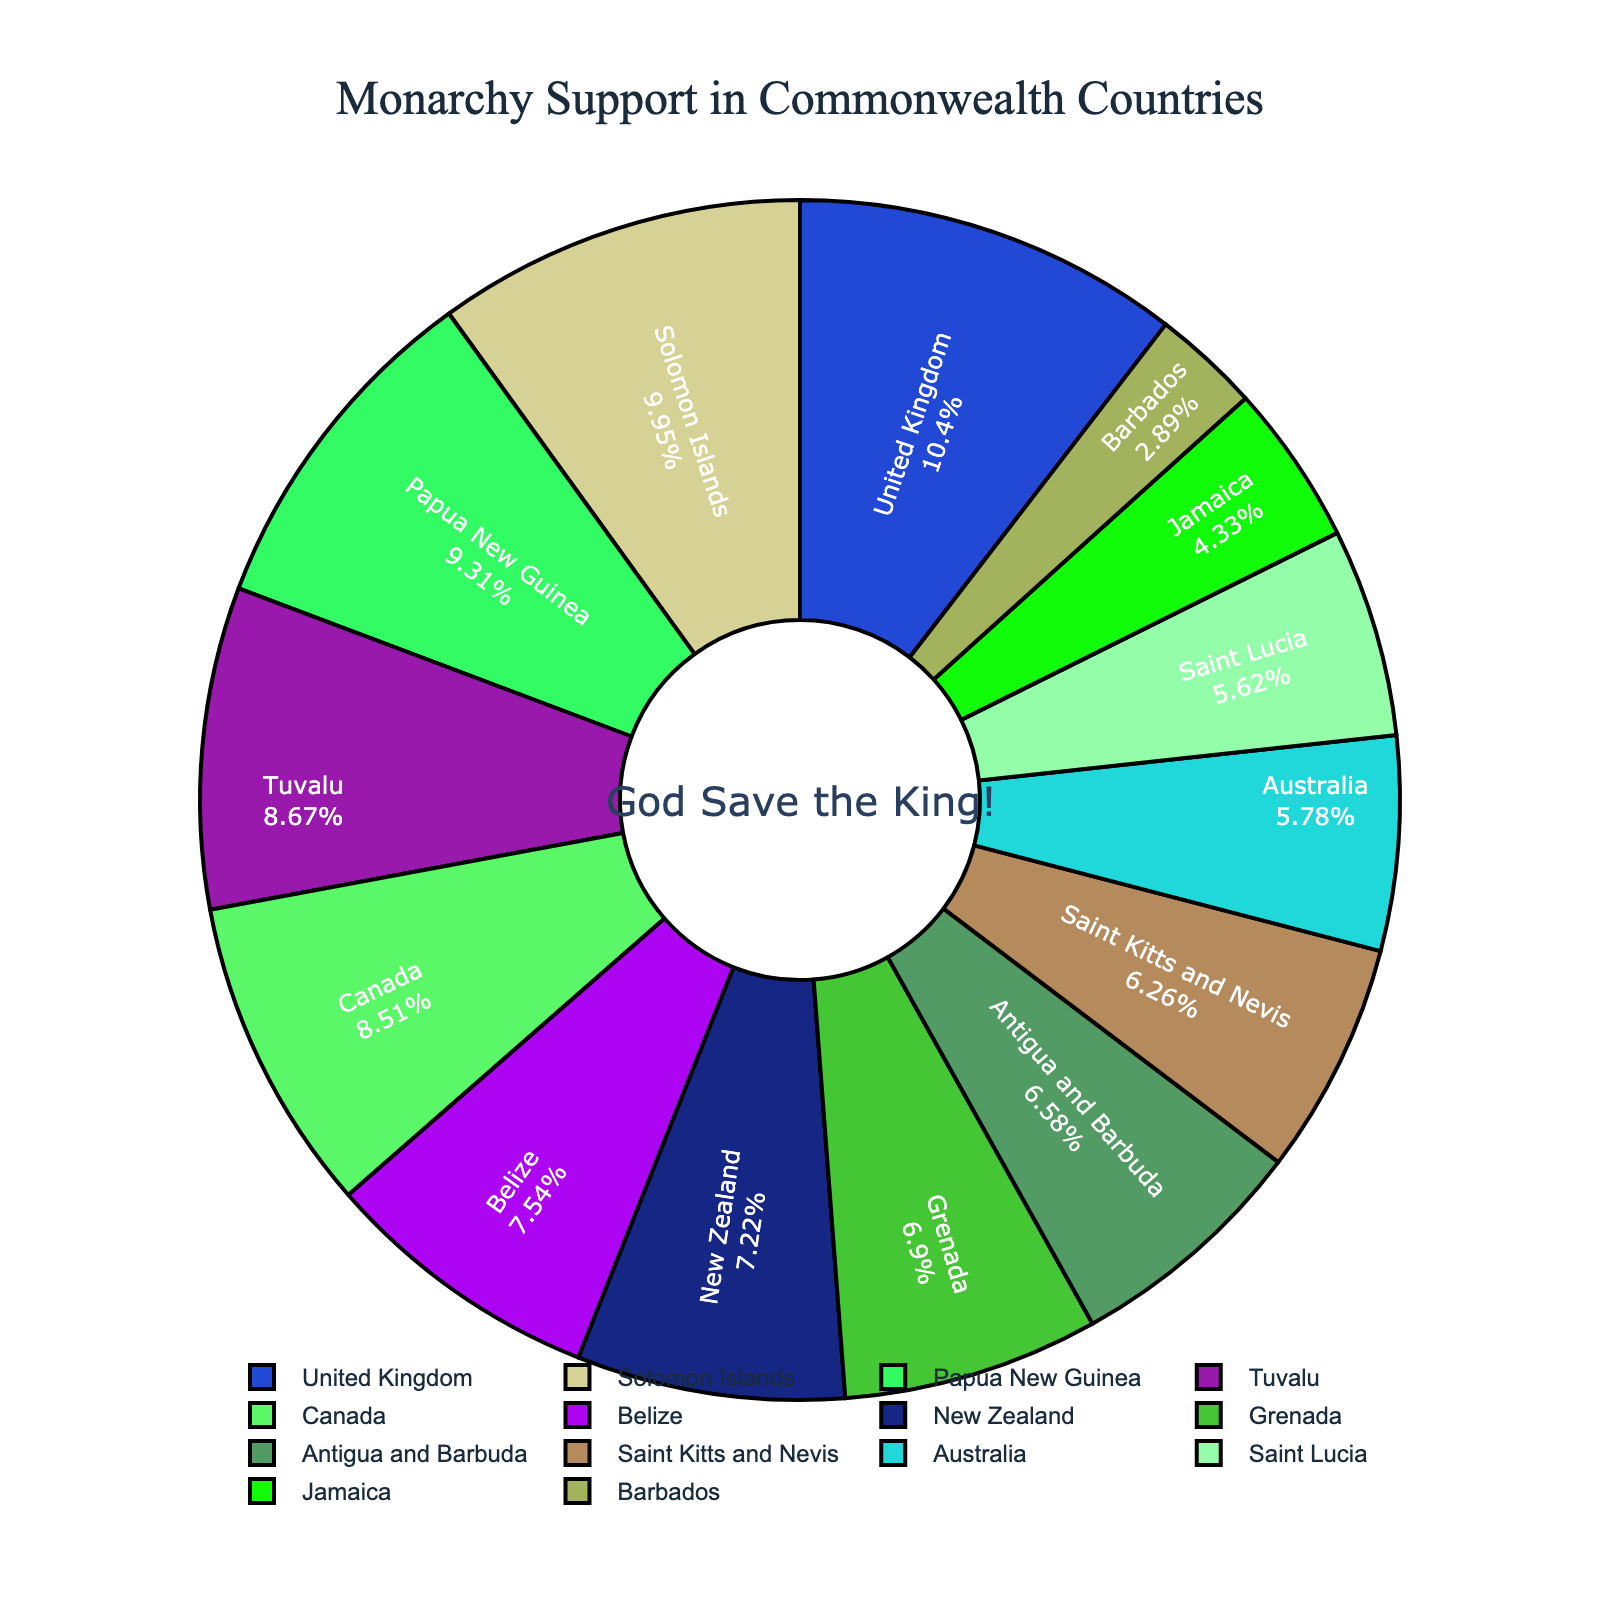What percentage of support does the United Kingdom have and how does it compare to Canada? The United Kingdom has 65% support, and Canada has 53%. To compare, subtract Canada's support from the United Kingdom's support: 65% - 53% = 12%.
Answer: 12% Which country shows the highest support for the British monarchy, and which shows the lowest? By examining the pie chart, we see that the Solomon Islands have the highest support at 62%, and Barbados has the lowest support at 18%.
Answer: Solomon Islands, Barbados If you combine the support percentages of New Zealand, Australia, and Jamaica, what total do you get? Add the support percentages of New Zealand (45%), Australia (36%), and Jamaica (27%): 45% + 36% + 27% = 108%.
Answer: 108% What is the average support percentage for the countries listed in the chart? To find the average, sum all support percentages and divide by the number of countries. The total sum is 65+53+36+45+27+18+58+62+41+39+47+43+35+54 = 623. There are 14 countries, so the average is 623/14 ≈ 44.5%.
Answer: 44.5% Which three countries have support percentages closest to 50%? In the pie chart, the countries closest to 50% are Canada (53%), Tuvalu (54%), and Papua New Guinea (58%).
Answer: Canada, Tuvalu, Papua New Guinea How much greater is the support for the monarchy in Tuvalu than in Barbados? Subtract Barbados' support (18%) from Tuvalu's support (54%): 54% - 18% = 36%.
Answer: 36% Which country has the support percentage closest to but not exceeding the average? The average is approximately 44.5%. Grenada (43%) is the closest support percentage to this average without exceeding it.
Answer: Grenada Rank the top five Commonwealth countries in terms of their support for the British monarchy. The top five countries by support for the British monarchy are Solomon Islands (62%), United Kingdom (65%), Papua New Guinea (58%), Tuvalu (54%), and Canada (53%).
Answer: Solomon Islands, United Kingdom, Papua New Guinea, Tuvalu, Canada How does the overall support for the British monarchy in the Caribbean countries (Jamaica, Barbados, Antigua and Barbuda, Saint Kitts and Nevis, Belize, Grenada, Saint Lucia) compare? Sum the support percentages for these Caribbean countries: Jamaica (27%), Barbados (18%), Antigua and Barbuda (41%), Saint Kitts and Nevis (39%), Belize (47%), Grenada (43%), Saint Lucia (35%). The total is 27+18+41+39+47+43+35=250. The average support across these 7 countries is 250/7 ≈ 35.7%.
Answer: 35.7% 